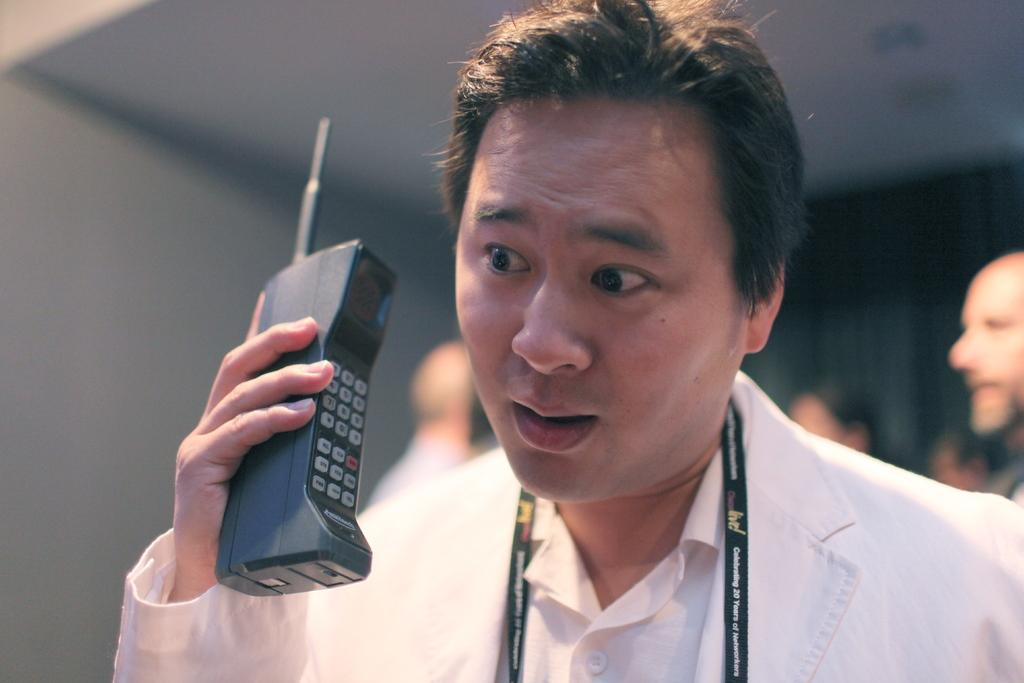What is the main subject of the image? There is a person in the image. What is the person wearing? The person is wearing clothes. What object is the person holding in his hand? The person is holding a phone in his hand. Can you describe the background of the image? The background of the image is blurred. What type of ray can be seen swimming in the background of the image? There is no ray present in the image; the background is blurred. What color is the coat the person is wearing in the image? The provided facts do not mention the color of the person's coat. 